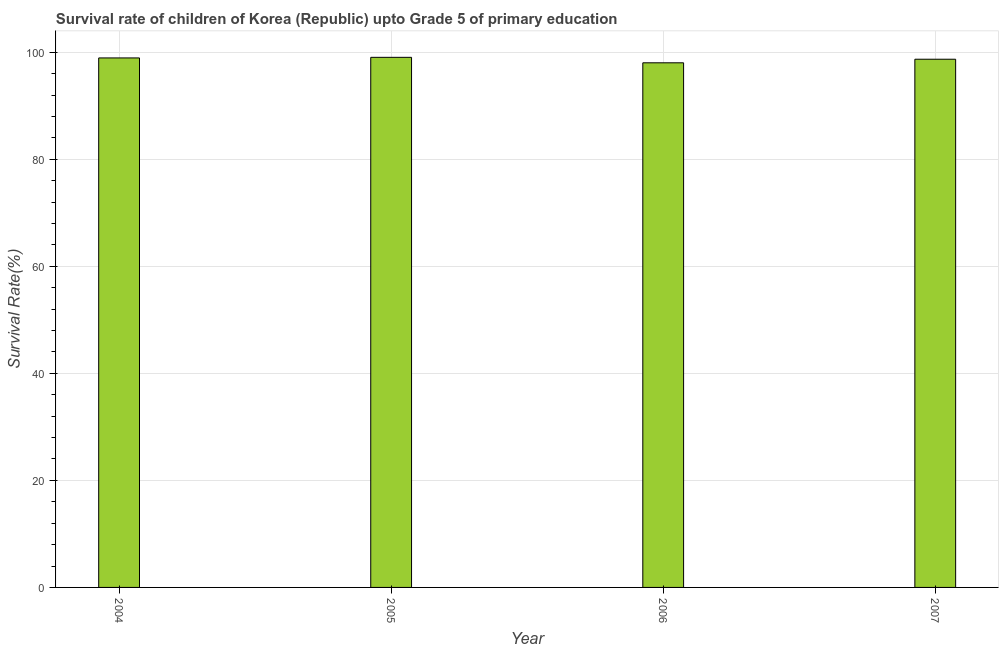Does the graph contain any zero values?
Your response must be concise. No. What is the title of the graph?
Your answer should be compact. Survival rate of children of Korea (Republic) upto Grade 5 of primary education. What is the label or title of the X-axis?
Make the answer very short. Year. What is the label or title of the Y-axis?
Provide a succinct answer. Survival Rate(%). What is the survival rate in 2005?
Ensure brevity in your answer.  99.04. Across all years, what is the maximum survival rate?
Your response must be concise. 99.04. Across all years, what is the minimum survival rate?
Provide a short and direct response. 98.02. In which year was the survival rate maximum?
Provide a short and direct response. 2005. In which year was the survival rate minimum?
Make the answer very short. 2006. What is the sum of the survival rate?
Give a very brief answer. 394.68. What is the difference between the survival rate in 2004 and 2007?
Your response must be concise. 0.24. What is the average survival rate per year?
Your response must be concise. 98.67. What is the median survival rate?
Keep it short and to the point. 98.81. Do a majority of the years between 2006 and 2005 (inclusive) have survival rate greater than 52 %?
Offer a terse response. No. Is the difference between the survival rate in 2004 and 2006 greater than the difference between any two years?
Offer a very short reply. No. What is the difference between the highest and the second highest survival rate?
Keep it short and to the point. 0.11. What is the difference between the highest and the lowest survival rate?
Ensure brevity in your answer.  1.02. How many bars are there?
Your answer should be very brief. 4. Are all the bars in the graph horizontal?
Provide a short and direct response. No. How many years are there in the graph?
Provide a succinct answer. 4. What is the difference between two consecutive major ticks on the Y-axis?
Keep it short and to the point. 20. What is the Survival Rate(%) in 2004?
Keep it short and to the point. 98.93. What is the Survival Rate(%) in 2005?
Keep it short and to the point. 99.04. What is the Survival Rate(%) in 2006?
Provide a succinct answer. 98.02. What is the Survival Rate(%) in 2007?
Give a very brief answer. 98.69. What is the difference between the Survival Rate(%) in 2004 and 2005?
Ensure brevity in your answer.  -0.11. What is the difference between the Survival Rate(%) in 2004 and 2006?
Your response must be concise. 0.91. What is the difference between the Survival Rate(%) in 2004 and 2007?
Make the answer very short. 0.24. What is the difference between the Survival Rate(%) in 2005 and 2006?
Ensure brevity in your answer.  1.02. What is the difference between the Survival Rate(%) in 2005 and 2007?
Ensure brevity in your answer.  0.36. What is the difference between the Survival Rate(%) in 2006 and 2007?
Ensure brevity in your answer.  -0.67. What is the ratio of the Survival Rate(%) in 2004 to that in 2005?
Keep it short and to the point. 1. What is the ratio of the Survival Rate(%) in 2004 to that in 2006?
Your answer should be compact. 1.01. What is the ratio of the Survival Rate(%) in 2004 to that in 2007?
Give a very brief answer. 1. What is the ratio of the Survival Rate(%) in 2005 to that in 2006?
Ensure brevity in your answer.  1.01. What is the ratio of the Survival Rate(%) in 2005 to that in 2007?
Make the answer very short. 1. 